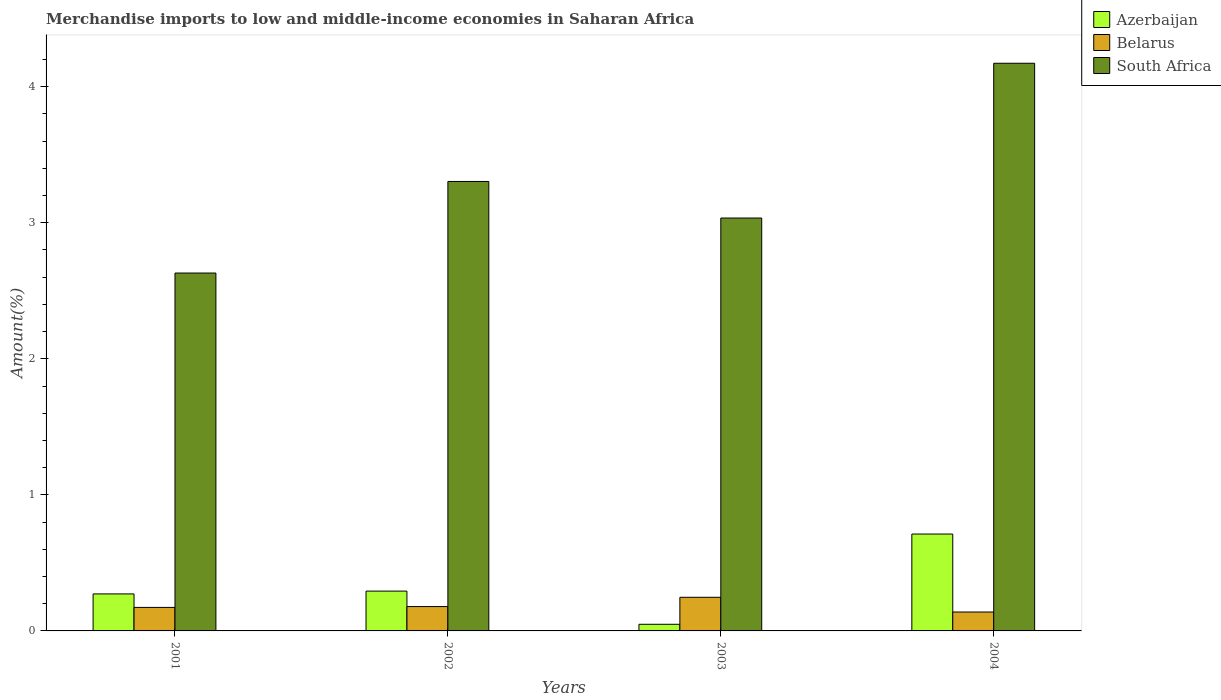How many different coloured bars are there?
Make the answer very short. 3. How many groups of bars are there?
Your answer should be very brief. 4. How many bars are there on the 2nd tick from the left?
Ensure brevity in your answer.  3. How many bars are there on the 4th tick from the right?
Your answer should be compact. 3. What is the percentage of amount earned from merchandise imports in Azerbaijan in 2002?
Your response must be concise. 0.29. Across all years, what is the maximum percentage of amount earned from merchandise imports in Azerbaijan?
Your response must be concise. 0.71. Across all years, what is the minimum percentage of amount earned from merchandise imports in Belarus?
Provide a succinct answer. 0.14. In which year was the percentage of amount earned from merchandise imports in Azerbaijan minimum?
Your response must be concise. 2003. What is the total percentage of amount earned from merchandise imports in Azerbaijan in the graph?
Keep it short and to the point. 1.33. What is the difference between the percentage of amount earned from merchandise imports in South Africa in 2003 and that in 2004?
Make the answer very short. -1.14. What is the difference between the percentage of amount earned from merchandise imports in South Africa in 2003 and the percentage of amount earned from merchandise imports in Belarus in 2001?
Keep it short and to the point. 2.86. What is the average percentage of amount earned from merchandise imports in Azerbaijan per year?
Ensure brevity in your answer.  0.33. In the year 2001, what is the difference between the percentage of amount earned from merchandise imports in South Africa and percentage of amount earned from merchandise imports in Azerbaijan?
Offer a terse response. 2.36. In how many years, is the percentage of amount earned from merchandise imports in South Africa greater than 2.4 %?
Make the answer very short. 4. What is the ratio of the percentage of amount earned from merchandise imports in Belarus in 2001 to that in 2002?
Provide a succinct answer. 0.97. Is the difference between the percentage of amount earned from merchandise imports in South Africa in 2001 and 2002 greater than the difference between the percentage of amount earned from merchandise imports in Azerbaijan in 2001 and 2002?
Make the answer very short. No. What is the difference between the highest and the second highest percentage of amount earned from merchandise imports in Belarus?
Offer a terse response. 0.07. What is the difference between the highest and the lowest percentage of amount earned from merchandise imports in South Africa?
Your response must be concise. 1.54. In how many years, is the percentage of amount earned from merchandise imports in Azerbaijan greater than the average percentage of amount earned from merchandise imports in Azerbaijan taken over all years?
Give a very brief answer. 1. Is the sum of the percentage of amount earned from merchandise imports in Belarus in 2001 and 2003 greater than the maximum percentage of amount earned from merchandise imports in Azerbaijan across all years?
Your answer should be very brief. No. What does the 2nd bar from the left in 2002 represents?
Keep it short and to the point. Belarus. What does the 3rd bar from the right in 2002 represents?
Provide a short and direct response. Azerbaijan. How many bars are there?
Your answer should be very brief. 12. How many years are there in the graph?
Your answer should be compact. 4. Where does the legend appear in the graph?
Provide a short and direct response. Top right. How many legend labels are there?
Your response must be concise. 3. What is the title of the graph?
Offer a terse response. Merchandise imports to low and middle-income economies in Saharan Africa. What is the label or title of the Y-axis?
Ensure brevity in your answer.  Amount(%). What is the Amount(%) in Azerbaijan in 2001?
Ensure brevity in your answer.  0.27. What is the Amount(%) of Belarus in 2001?
Keep it short and to the point. 0.17. What is the Amount(%) in South Africa in 2001?
Keep it short and to the point. 2.63. What is the Amount(%) of Azerbaijan in 2002?
Provide a succinct answer. 0.29. What is the Amount(%) of Belarus in 2002?
Ensure brevity in your answer.  0.18. What is the Amount(%) of South Africa in 2002?
Your answer should be compact. 3.3. What is the Amount(%) in Azerbaijan in 2003?
Your response must be concise. 0.05. What is the Amount(%) in Belarus in 2003?
Provide a short and direct response. 0.25. What is the Amount(%) in South Africa in 2003?
Give a very brief answer. 3.03. What is the Amount(%) of Azerbaijan in 2004?
Keep it short and to the point. 0.71. What is the Amount(%) of Belarus in 2004?
Offer a very short reply. 0.14. What is the Amount(%) in South Africa in 2004?
Offer a terse response. 4.17. Across all years, what is the maximum Amount(%) in Azerbaijan?
Your answer should be very brief. 0.71. Across all years, what is the maximum Amount(%) in Belarus?
Ensure brevity in your answer.  0.25. Across all years, what is the maximum Amount(%) of South Africa?
Offer a terse response. 4.17. Across all years, what is the minimum Amount(%) of Azerbaijan?
Ensure brevity in your answer.  0.05. Across all years, what is the minimum Amount(%) in Belarus?
Make the answer very short. 0.14. Across all years, what is the minimum Amount(%) in South Africa?
Your answer should be compact. 2.63. What is the total Amount(%) of Azerbaijan in the graph?
Your response must be concise. 1.33. What is the total Amount(%) in Belarus in the graph?
Provide a short and direct response. 0.74. What is the total Amount(%) of South Africa in the graph?
Keep it short and to the point. 13.14. What is the difference between the Amount(%) of Azerbaijan in 2001 and that in 2002?
Give a very brief answer. -0.02. What is the difference between the Amount(%) of Belarus in 2001 and that in 2002?
Your response must be concise. -0.01. What is the difference between the Amount(%) in South Africa in 2001 and that in 2002?
Your response must be concise. -0.67. What is the difference between the Amount(%) in Azerbaijan in 2001 and that in 2003?
Your answer should be compact. 0.22. What is the difference between the Amount(%) in Belarus in 2001 and that in 2003?
Your answer should be compact. -0.07. What is the difference between the Amount(%) of South Africa in 2001 and that in 2003?
Keep it short and to the point. -0.4. What is the difference between the Amount(%) of Azerbaijan in 2001 and that in 2004?
Your answer should be very brief. -0.44. What is the difference between the Amount(%) of Belarus in 2001 and that in 2004?
Provide a short and direct response. 0.03. What is the difference between the Amount(%) in South Africa in 2001 and that in 2004?
Your answer should be compact. -1.54. What is the difference between the Amount(%) in Azerbaijan in 2002 and that in 2003?
Offer a very short reply. 0.24. What is the difference between the Amount(%) in Belarus in 2002 and that in 2003?
Give a very brief answer. -0.07. What is the difference between the Amount(%) of South Africa in 2002 and that in 2003?
Give a very brief answer. 0.27. What is the difference between the Amount(%) of Azerbaijan in 2002 and that in 2004?
Keep it short and to the point. -0.42. What is the difference between the Amount(%) of Belarus in 2002 and that in 2004?
Provide a succinct answer. 0.04. What is the difference between the Amount(%) of South Africa in 2002 and that in 2004?
Make the answer very short. -0.87. What is the difference between the Amount(%) of Azerbaijan in 2003 and that in 2004?
Your answer should be compact. -0.66. What is the difference between the Amount(%) of Belarus in 2003 and that in 2004?
Offer a very short reply. 0.11. What is the difference between the Amount(%) in South Africa in 2003 and that in 2004?
Your response must be concise. -1.14. What is the difference between the Amount(%) in Azerbaijan in 2001 and the Amount(%) in Belarus in 2002?
Provide a succinct answer. 0.09. What is the difference between the Amount(%) in Azerbaijan in 2001 and the Amount(%) in South Africa in 2002?
Make the answer very short. -3.03. What is the difference between the Amount(%) in Belarus in 2001 and the Amount(%) in South Africa in 2002?
Your answer should be compact. -3.13. What is the difference between the Amount(%) of Azerbaijan in 2001 and the Amount(%) of Belarus in 2003?
Your answer should be very brief. 0.02. What is the difference between the Amount(%) of Azerbaijan in 2001 and the Amount(%) of South Africa in 2003?
Make the answer very short. -2.76. What is the difference between the Amount(%) in Belarus in 2001 and the Amount(%) in South Africa in 2003?
Give a very brief answer. -2.86. What is the difference between the Amount(%) of Azerbaijan in 2001 and the Amount(%) of Belarus in 2004?
Provide a short and direct response. 0.13. What is the difference between the Amount(%) in Azerbaijan in 2001 and the Amount(%) in South Africa in 2004?
Provide a succinct answer. -3.9. What is the difference between the Amount(%) in Belarus in 2001 and the Amount(%) in South Africa in 2004?
Offer a very short reply. -4. What is the difference between the Amount(%) in Azerbaijan in 2002 and the Amount(%) in Belarus in 2003?
Your answer should be very brief. 0.05. What is the difference between the Amount(%) in Azerbaijan in 2002 and the Amount(%) in South Africa in 2003?
Provide a succinct answer. -2.74. What is the difference between the Amount(%) of Belarus in 2002 and the Amount(%) of South Africa in 2003?
Offer a terse response. -2.86. What is the difference between the Amount(%) in Azerbaijan in 2002 and the Amount(%) in Belarus in 2004?
Offer a very short reply. 0.15. What is the difference between the Amount(%) of Azerbaijan in 2002 and the Amount(%) of South Africa in 2004?
Make the answer very short. -3.88. What is the difference between the Amount(%) in Belarus in 2002 and the Amount(%) in South Africa in 2004?
Your answer should be very brief. -3.99. What is the difference between the Amount(%) of Azerbaijan in 2003 and the Amount(%) of Belarus in 2004?
Ensure brevity in your answer.  -0.09. What is the difference between the Amount(%) in Azerbaijan in 2003 and the Amount(%) in South Africa in 2004?
Provide a short and direct response. -4.12. What is the difference between the Amount(%) in Belarus in 2003 and the Amount(%) in South Africa in 2004?
Ensure brevity in your answer.  -3.92. What is the average Amount(%) of Azerbaijan per year?
Offer a very short reply. 0.33. What is the average Amount(%) in Belarus per year?
Provide a short and direct response. 0.18. What is the average Amount(%) of South Africa per year?
Offer a terse response. 3.29. In the year 2001, what is the difference between the Amount(%) in Azerbaijan and Amount(%) in Belarus?
Your answer should be compact. 0.1. In the year 2001, what is the difference between the Amount(%) in Azerbaijan and Amount(%) in South Africa?
Provide a succinct answer. -2.36. In the year 2001, what is the difference between the Amount(%) of Belarus and Amount(%) of South Africa?
Provide a short and direct response. -2.46. In the year 2002, what is the difference between the Amount(%) in Azerbaijan and Amount(%) in Belarus?
Provide a short and direct response. 0.11. In the year 2002, what is the difference between the Amount(%) in Azerbaijan and Amount(%) in South Africa?
Make the answer very short. -3.01. In the year 2002, what is the difference between the Amount(%) in Belarus and Amount(%) in South Africa?
Offer a very short reply. -3.12. In the year 2003, what is the difference between the Amount(%) of Azerbaijan and Amount(%) of Belarus?
Your answer should be very brief. -0.2. In the year 2003, what is the difference between the Amount(%) of Azerbaijan and Amount(%) of South Africa?
Your answer should be compact. -2.99. In the year 2003, what is the difference between the Amount(%) of Belarus and Amount(%) of South Africa?
Provide a succinct answer. -2.79. In the year 2004, what is the difference between the Amount(%) of Azerbaijan and Amount(%) of Belarus?
Your response must be concise. 0.57. In the year 2004, what is the difference between the Amount(%) of Azerbaijan and Amount(%) of South Africa?
Provide a succinct answer. -3.46. In the year 2004, what is the difference between the Amount(%) of Belarus and Amount(%) of South Africa?
Provide a short and direct response. -4.03. What is the ratio of the Amount(%) of Azerbaijan in 2001 to that in 2002?
Keep it short and to the point. 0.93. What is the ratio of the Amount(%) of Belarus in 2001 to that in 2002?
Give a very brief answer. 0.97. What is the ratio of the Amount(%) in South Africa in 2001 to that in 2002?
Ensure brevity in your answer.  0.8. What is the ratio of the Amount(%) of Azerbaijan in 2001 to that in 2003?
Ensure brevity in your answer.  5.57. What is the ratio of the Amount(%) in Belarus in 2001 to that in 2003?
Provide a short and direct response. 0.7. What is the ratio of the Amount(%) of South Africa in 2001 to that in 2003?
Offer a very short reply. 0.87. What is the ratio of the Amount(%) in Azerbaijan in 2001 to that in 2004?
Provide a succinct answer. 0.38. What is the ratio of the Amount(%) of Belarus in 2001 to that in 2004?
Keep it short and to the point. 1.24. What is the ratio of the Amount(%) in South Africa in 2001 to that in 2004?
Offer a terse response. 0.63. What is the ratio of the Amount(%) in Azerbaijan in 2002 to that in 2003?
Keep it short and to the point. 6. What is the ratio of the Amount(%) of Belarus in 2002 to that in 2003?
Provide a succinct answer. 0.72. What is the ratio of the Amount(%) in South Africa in 2002 to that in 2003?
Ensure brevity in your answer.  1.09. What is the ratio of the Amount(%) of Azerbaijan in 2002 to that in 2004?
Keep it short and to the point. 0.41. What is the ratio of the Amount(%) of Belarus in 2002 to that in 2004?
Give a very brief answer. 1.29. What is the ratio of the Amount(%) in South Africa in 2002 to that in 2004?
Give a very brief answer. 0.79. What is the ratio of the Amount(%) of Azerbaijan in 2003 to that in 2004?
Your answer should be very brief. 0.07. What is the ratio of the Amount(%) in Belarus in 2003 to that in 2004?
Provide a short and direct response. 1.78. What is the ratio of the Amount(%) in South Africa in 2003 to that in 2004?
Your response must be concise. 0.73. What is the difference between the highest and the second highest Amount(%) in Azerbaijan?
Offer a very short reply. 0.42. What is the difference between the highest and the second highest Amount(%) in Belarus?
Provide a succinct answer. 0.07. What is the difference between the highest and the second highest Amount(%) in South Africa?
Provide a succinct answer. 0.87. What is the difference between the highest and the lowest Amount(%) in Azerbaijan?
Provide a short and direct response. 0.66. What is the difference between the highest and the lowest Amount(%) of Belarus?
Offer a very short reply. 0.11. What is the difference between the highest and the lowest Amount(%) in South Africa?
Your answer should be very brief. 1.54. 